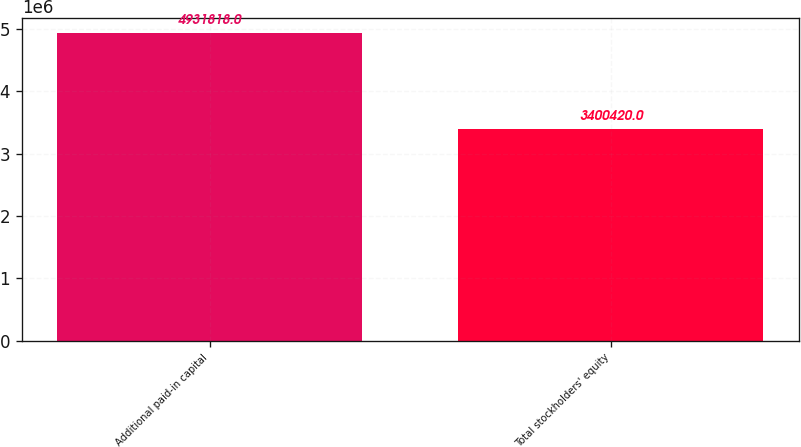Convert chart to OTSL. <chart><loc_0><loc_0><loc_500><loc_500><bar_chart><fcel>Additional paid-in capital<fcel>Total stockholders' equity<nl><fcel>4.93182e+06<fcel>3.40042e+06<nl></chart> 